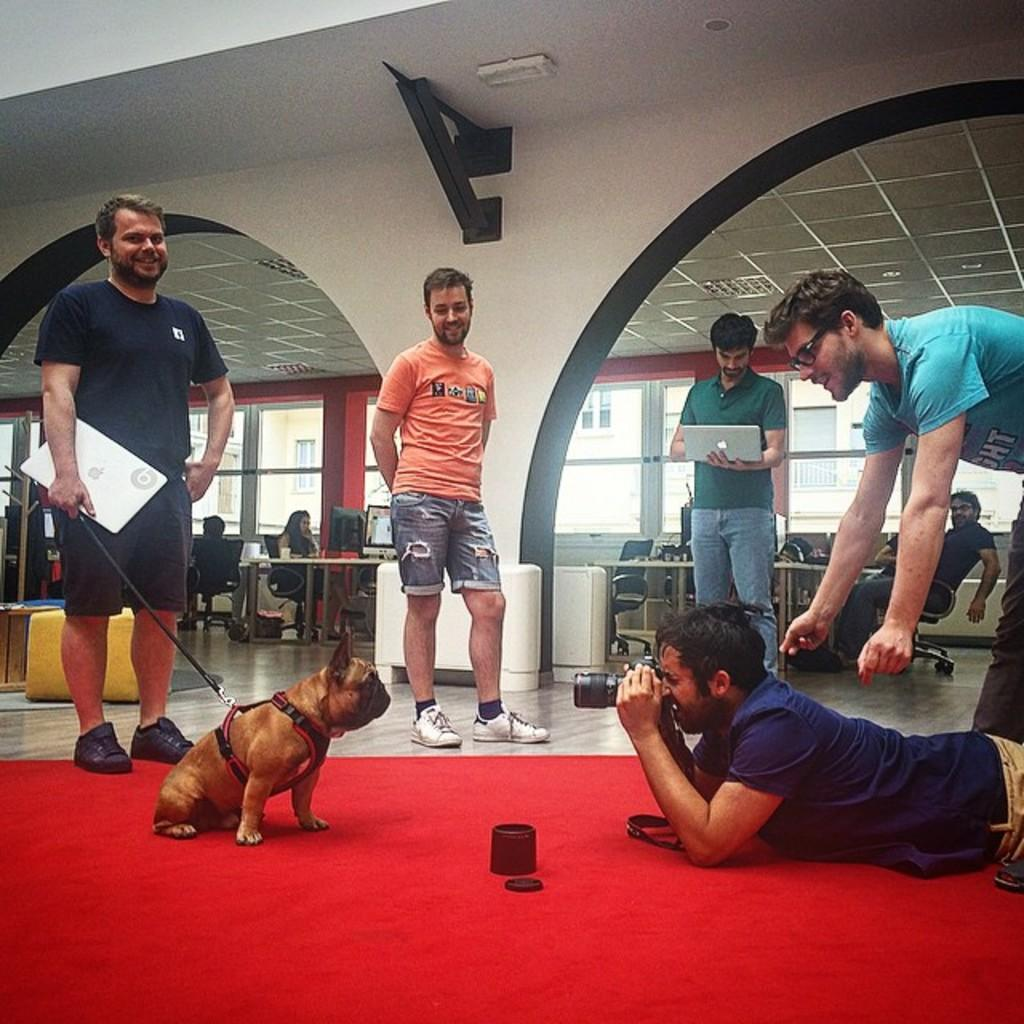What are the men in the image doing? Two of the men are holding laptops. What is the person on the floor doing? The person on the floor is capturing a dog's picture. Can you describe the people in the background? There are people sitting in chairs in the background. What type of instrument is the person on the floor playing in the image? There is no instrument present in the image; the person on the floor is capturing a dog's picture. Can you tell me how many buns are visible in the image? There are no buns present in the image. 